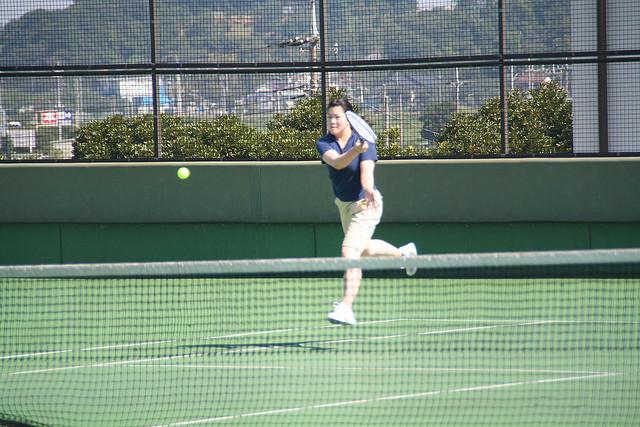What color pants is the woman wearing?
Quick response, please. White. What is the woman holding?
Answer briefly. Racket. Will she reach the ball?
Write a very short answer. Yes. Is the ball in the air?
Concise answer only. Yes. 